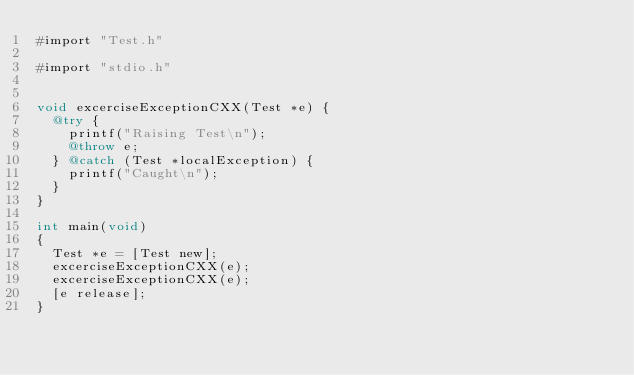<code> <loc_0><loc_0><loc_500><loc_500><_ObjectiveC_>#import "Test.h"

#import "stdio.h"


void excerciseExceptionCXX(Test *e) {
  @try {
    printf("Raising Test\n");
    @throw e;
  } @catch (Test *localException) {
    printf("Caught\n");
  }
}

int main(void)
{
  Test *e = [Test new];
  excerciseExceptionCXX(e);
  excerciseExceptionCXX(e);
  [e release];
}

</code> 